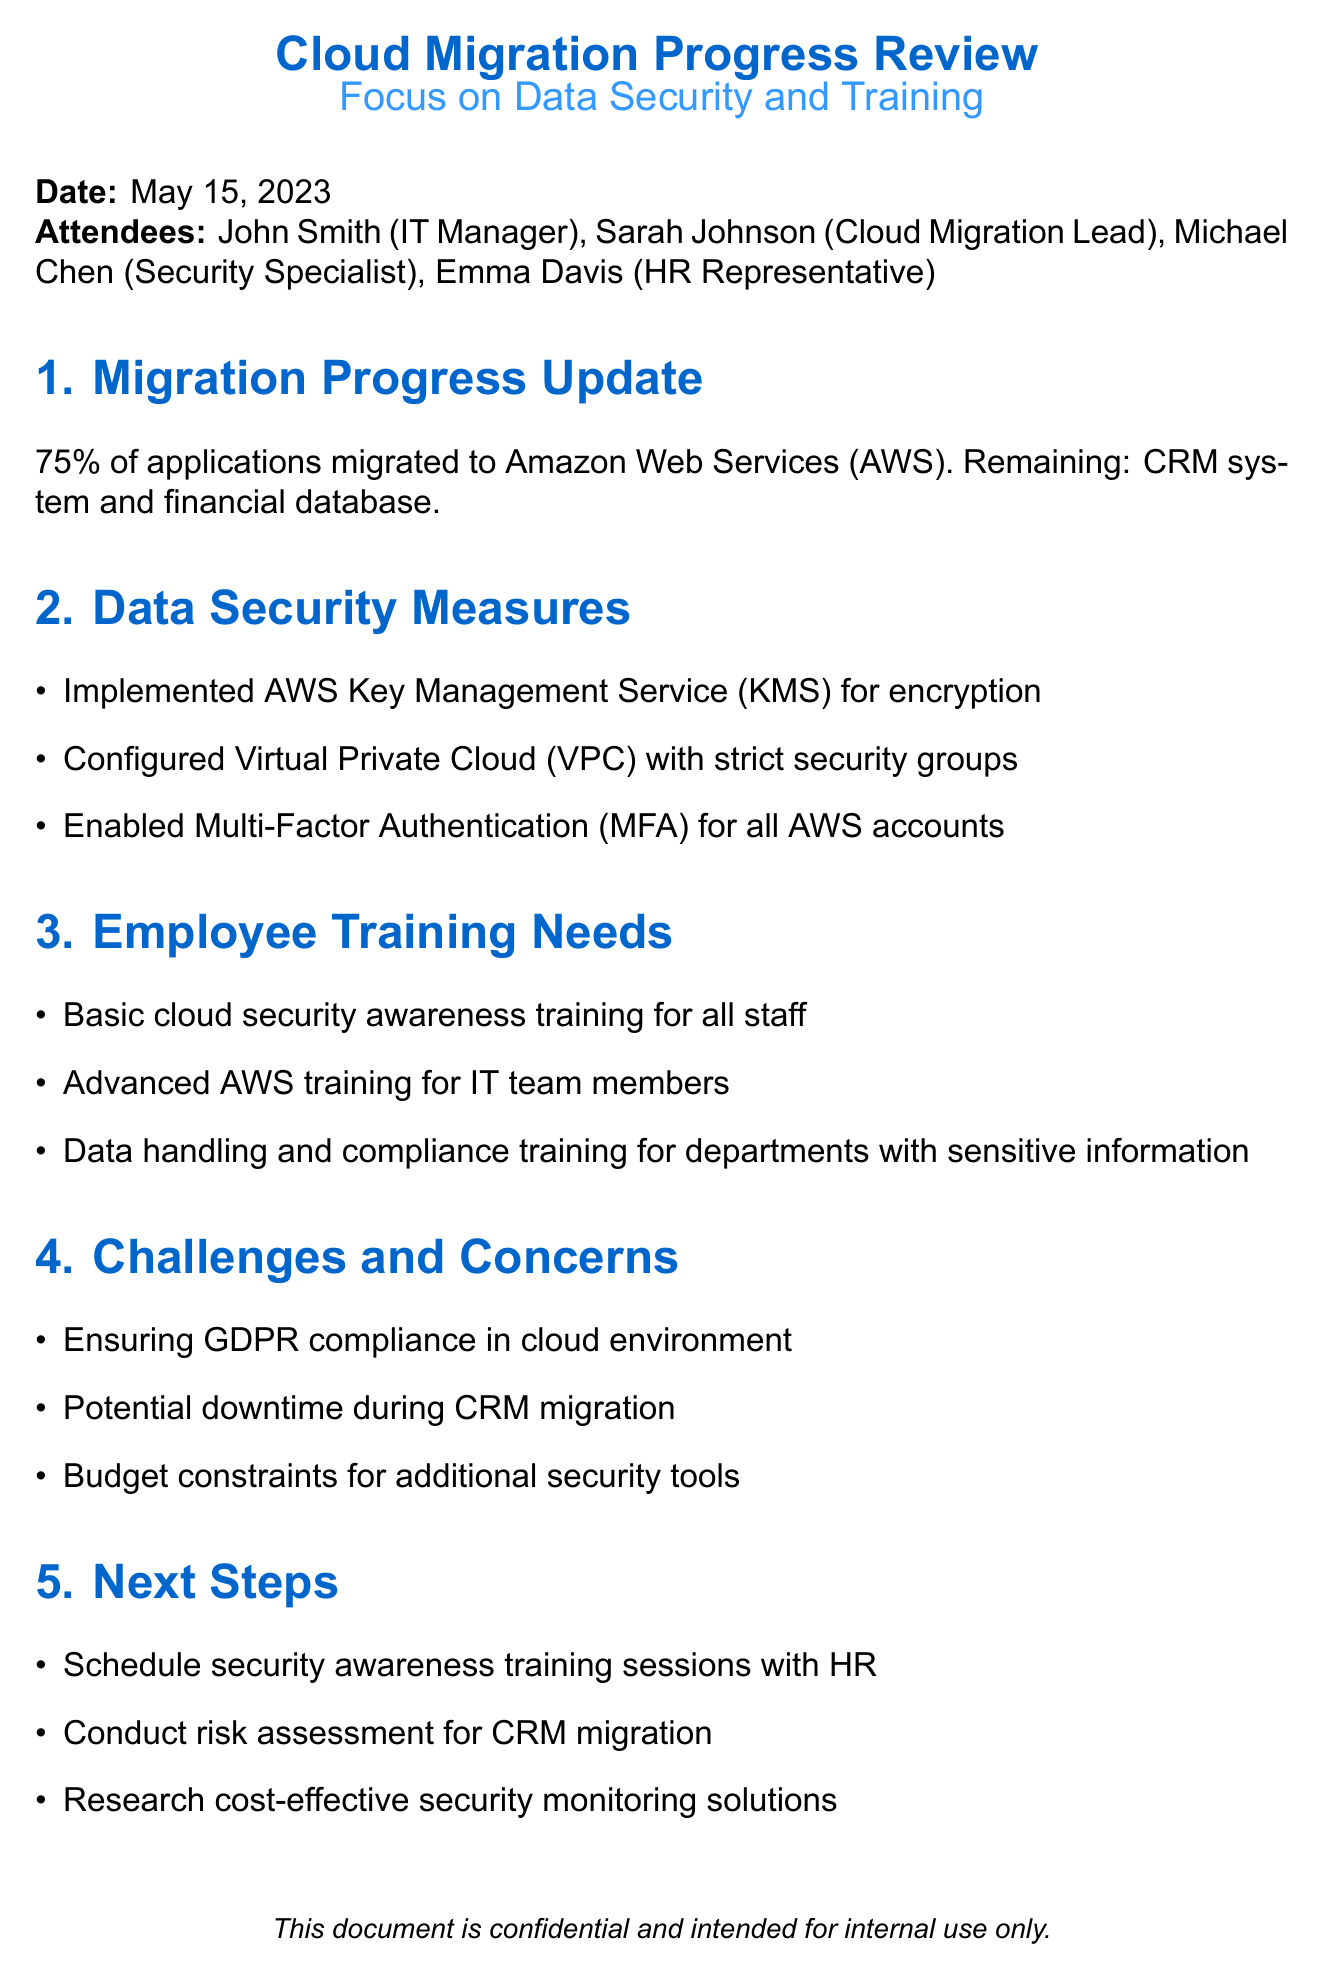What is the meeting title? The meeting title is directly stated at the beginning of the document.
Answer: Cloud Migration Progress Review - Focus on Data Security and Training What percentage of applications has been migrated to AWS? The percentage of applications migrated is explicitly mentioned in the migration update section.
Answer: 75% Which security measure is used for encryption? The security measure for encryption is specified in the data security measures section.
Answer: AWS Key Management Service (KMS) What type of training is needed for the IT team? The document lists specific training needs, including what is required for the IT department.
Answer: Advanced AWS training What is one challenge mentioned regarding data security? The document outlines challenges, and one specific challenge is easily retrievable from that section.
Answer: Ensuring GDPR compliance in cloud environment Who is responsible for scheduling training sessions? The next steps section mentions scheduling tasks and the responsible department.
Answer: HR What are the next steps regarding CRM migration? The next steps section includes actions that need to be taken related to CRM migration.
Answer: Conduct risk assessment for CRM migration What is one concern about the budget? The document addresses budget constraints in the context of cloud migration challenges.
Answer: Budget constraints for additional security tools 